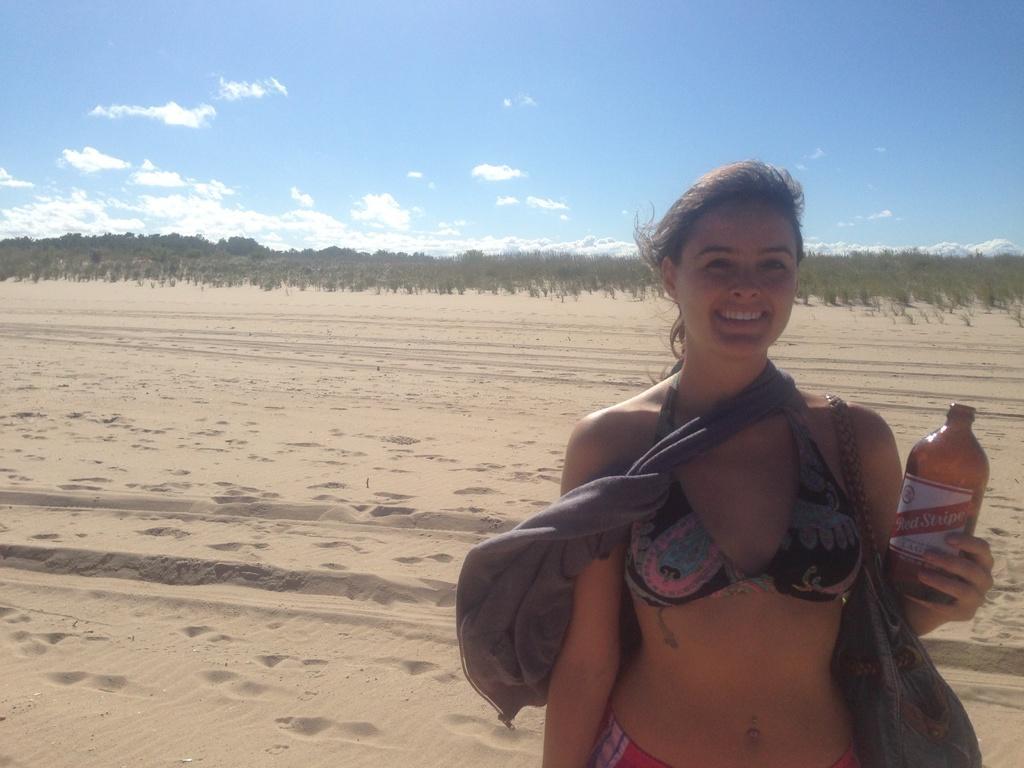In one or two sentences, can you explain what this image depicts? This is a picture of out side of a city and a woman stand and she is smiling and she holding a bottle and there is a sky and there are some trees visible. 